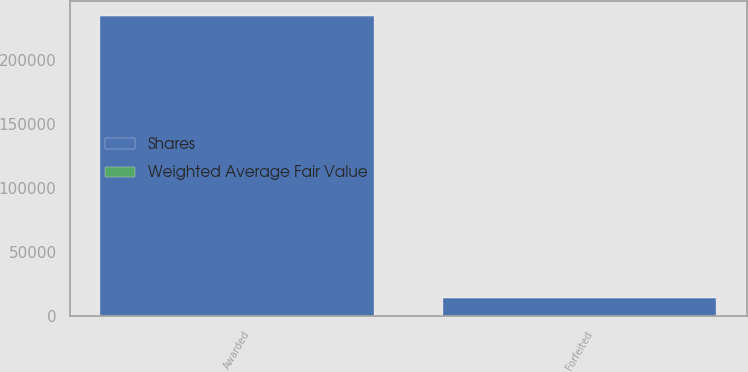<chart> <loc_0><loc_0><loc_500><loc_500><stacked_bar_chart><ecel><fcel>Awarded<fcel>Forfeited<nl><fcel>Shares<fcel>233939<fcel>13791<nl><fcel>Weighted Average Fair Value<fcel>90.12<fcel>78.42<nl></chart> 